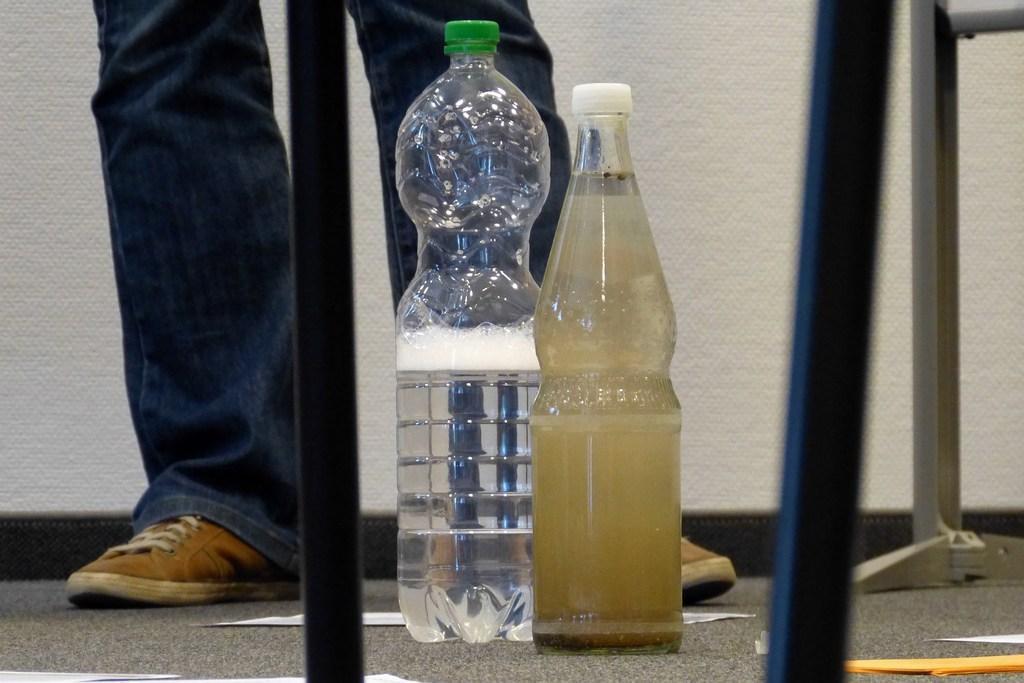Describe this image in one or two sentences. There are two bottles where one is pure water and the other one contains dirt water and there is a person wearing blue jeans in the background. 